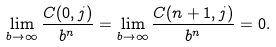<formula> <loc_0><loc_0><loc_500><loc_500>\lim _ { b \to \infty } \frac { C ( 0 , j ) } { b ^ { n } } = \lim _ { b \to \infty } \frac { C ( n + 1 , j ) } { b ^ { n } } = 0 .</formula> 